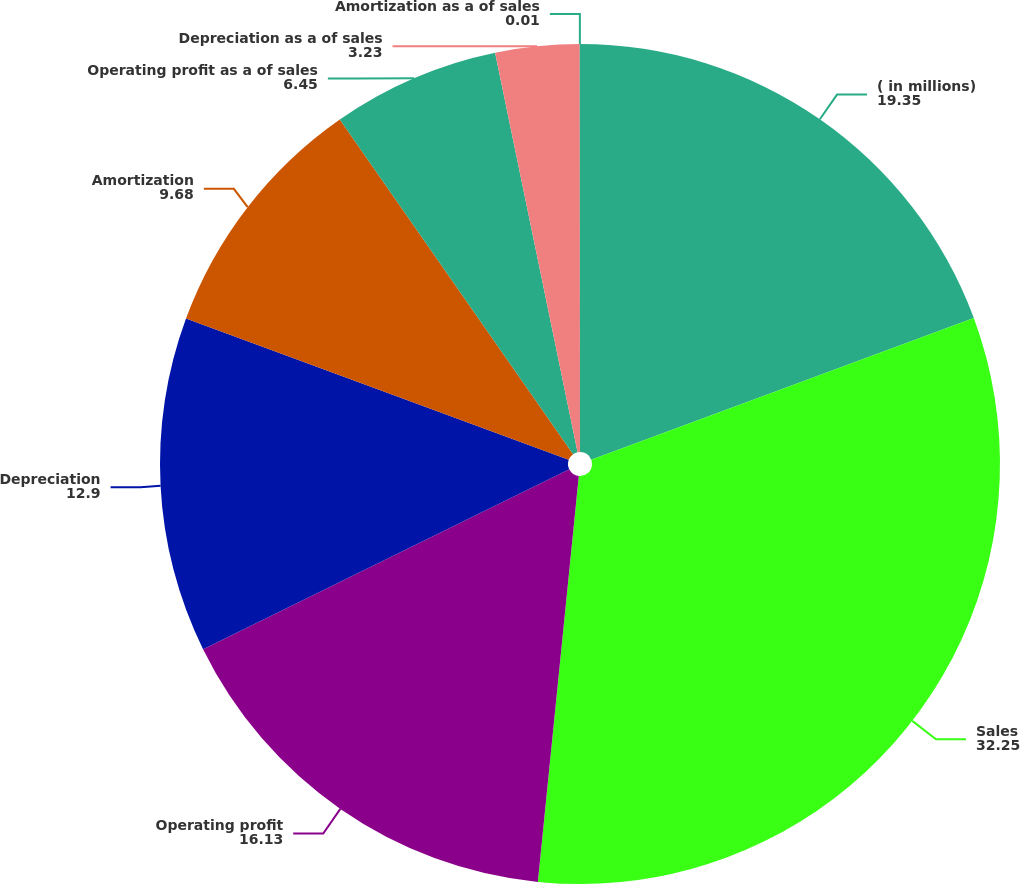Convert chart to OTSL. <chart><loc_0><loc_0><loc_500><loc_500><pie_chart><fcel>( in millions)<fcel>Sales<fcel>Operating profit<fcel>Depreciation<fcel>Amortization<fcel>Operating profit as a of sales<fcel>Depreciation as a of sales<fcel>Amortization as a of sales<nl><fcel>19.35%<fcel>32.25%<fcel>16.13%<fcel>12.9%<fcel>9.68%<fcel>6.45%<fcel>3.23%<fcel>0.01%<nl></chart> 